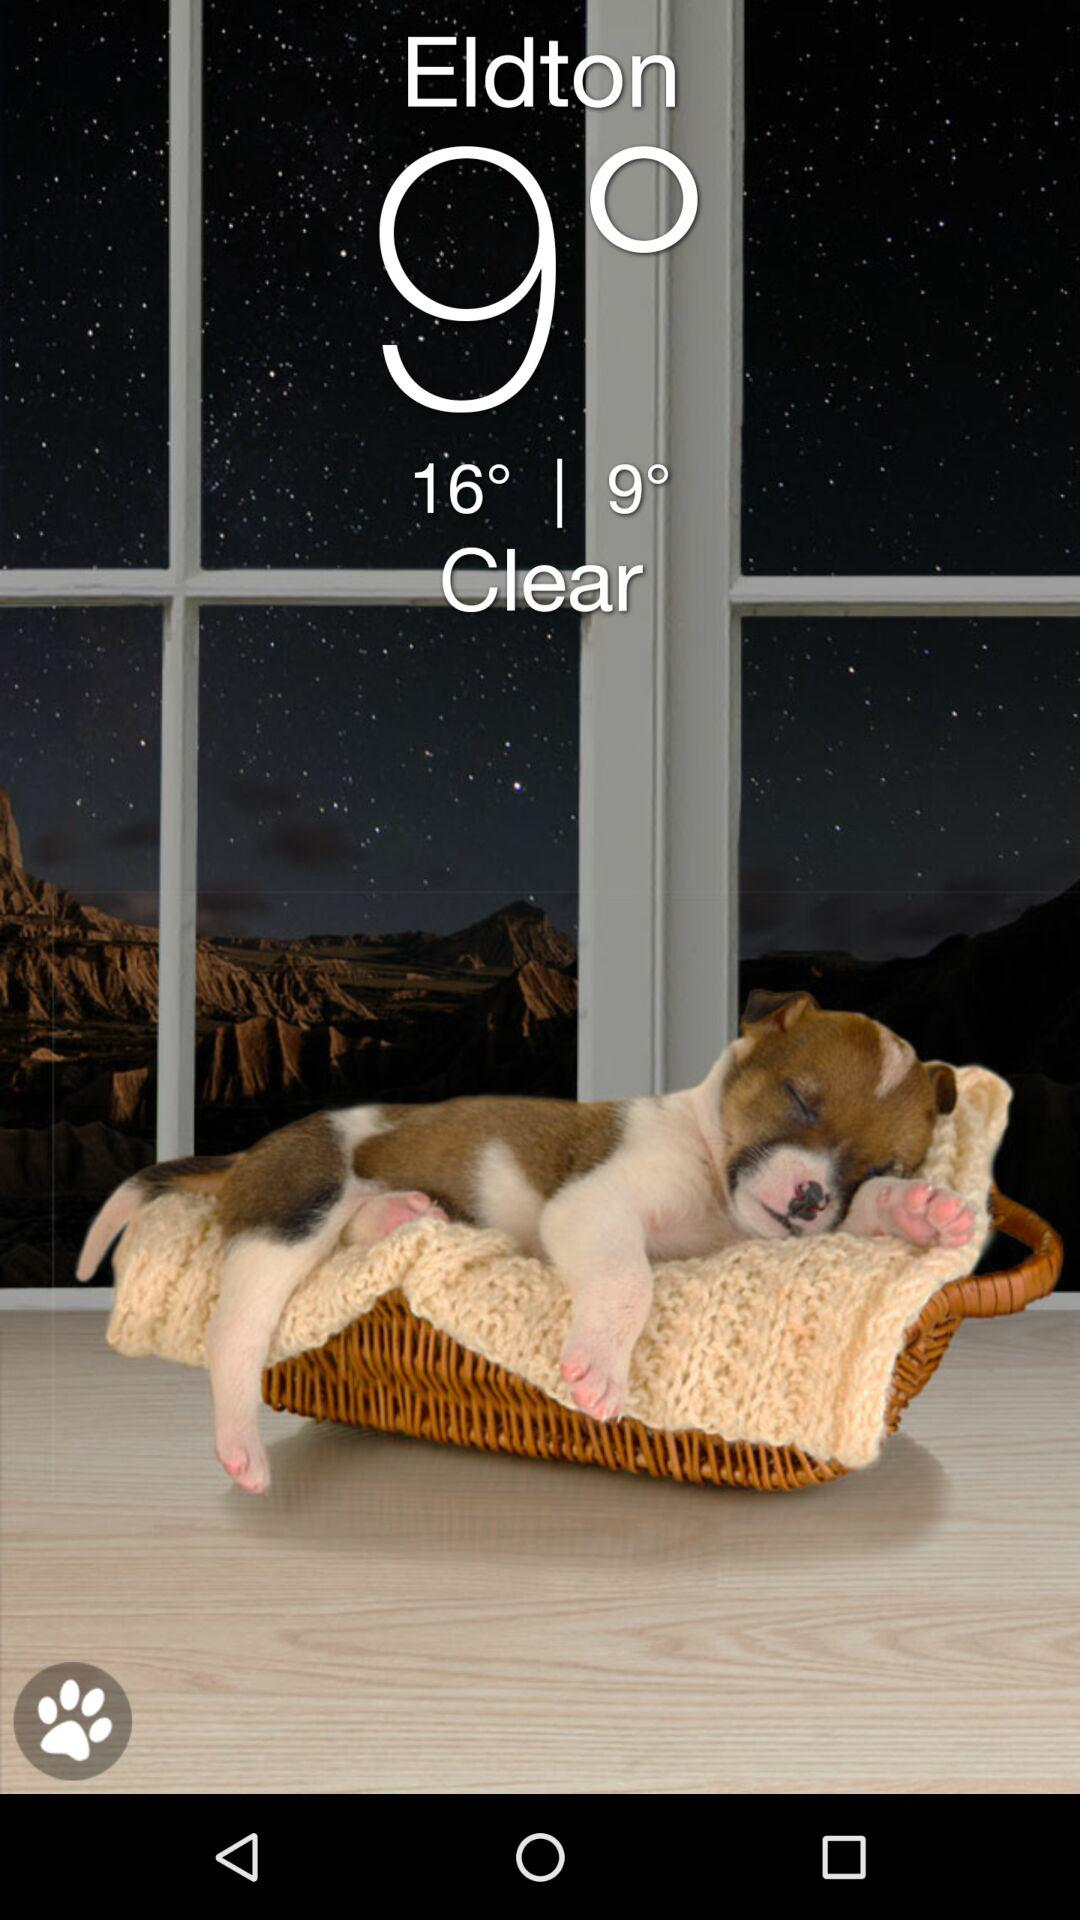Will it be clear again tomorrow?
When the provided information is insufficient, respond with <no answer>. <no answer> 